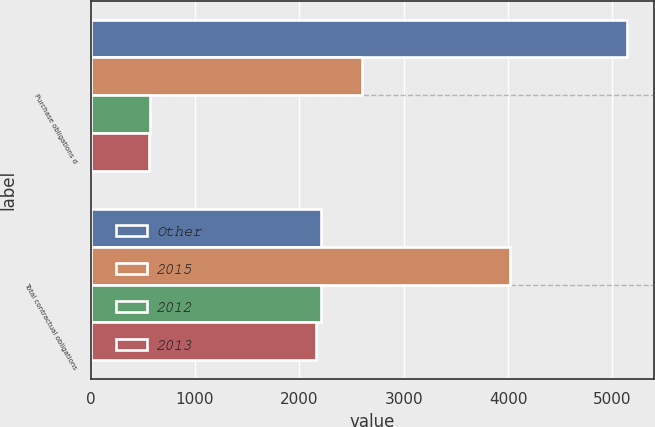Convert chart. <chart><loc_0><loc_0><loc_500><loc_500><stacked_bar_chart><ecel><fcel>Purchase obligations d<fcel>Total contractual obligations<nl><fcel>Other<fcel>5137<fcel>2204<nl><fcel>2015<fcel>2598<fcel>4015<nl><fcel>2012<fcel>568<fcel>2204<nl><fcel>2013<fcel>560<fcel>2164<nl></chart> 